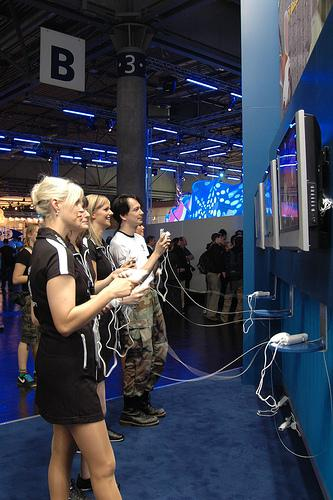Question: what are they doing?
Choices:
A. Watching TV.
B. Eating.
C. Sleeping.
D. Playing video game.
Answer with the letter. Answer: D Question: where is this scene?
Choices:
A. Restaurant.
B. Zoo.
C. Hospital.
D. Convention.
Answer with the letter. Answer: D Question: who is there?
Choices:
A. The mailman.
B. Young men and women.
C. A Doctor.
D. The judge.
Answer with the letter. Answer: B Question: why are they there?
Choices:
A. To have fun.
B. To gamble.
C. To win.
D. To play.
Answer with the letter. Answer: D 